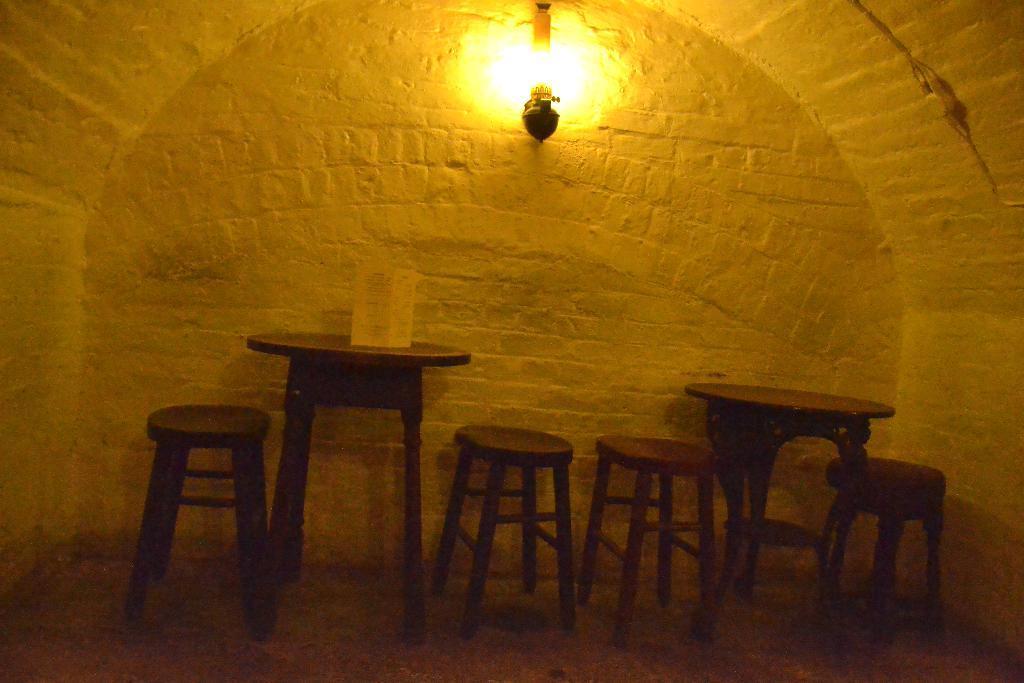How would you summarize this image in a sentence or two? In this picture I can see few tables and placard on the one of the table and light on the top to the wall. 